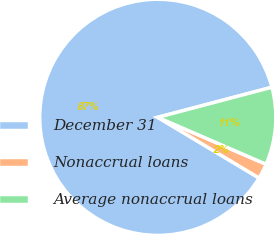Convert chart to OTSL. <chart><loc_0><loc_0><loc_500><loc_500><pie_chart><fcel>December 31<fcel>Nonaccrual loans<fcel>Average nonaccrual loans<nl><fcel>87.31%<fcel>2.08%<fcel>10.61%<nl></chart> 